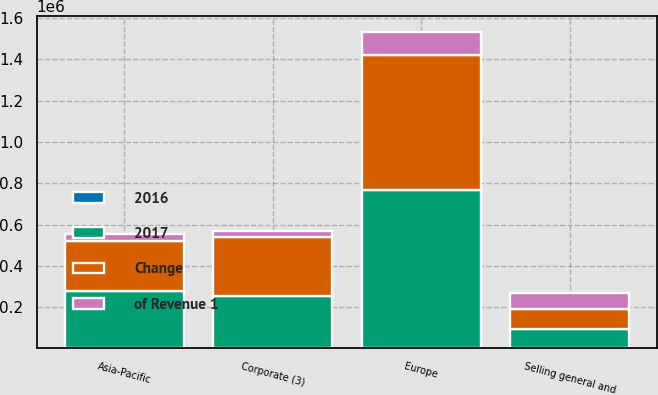Convert chart. <chart><loc_0><loc_0><loc_500><loc_500><stacked_bar_chart><ecel><fcel>Europe<fcel>Asia-Pacific<fcel>Selling general and<fcel>Corporate (3)<nl><fcel>2017<fcel>767524<fcel>278117<fcel>94604.5<fcel>252183<nl><fcel>2016<fcel>19.3<fcel>7<fcel>37.4<fcel>6.3<nl><fcel>Change<fcel>655477<fcel>240176<fcel>94604.5<fcel>285534<nl><fcel>of Revenue 1<fcel>112047<fcel>37941<fcel>77162<fcel>33351<nl></chart> 